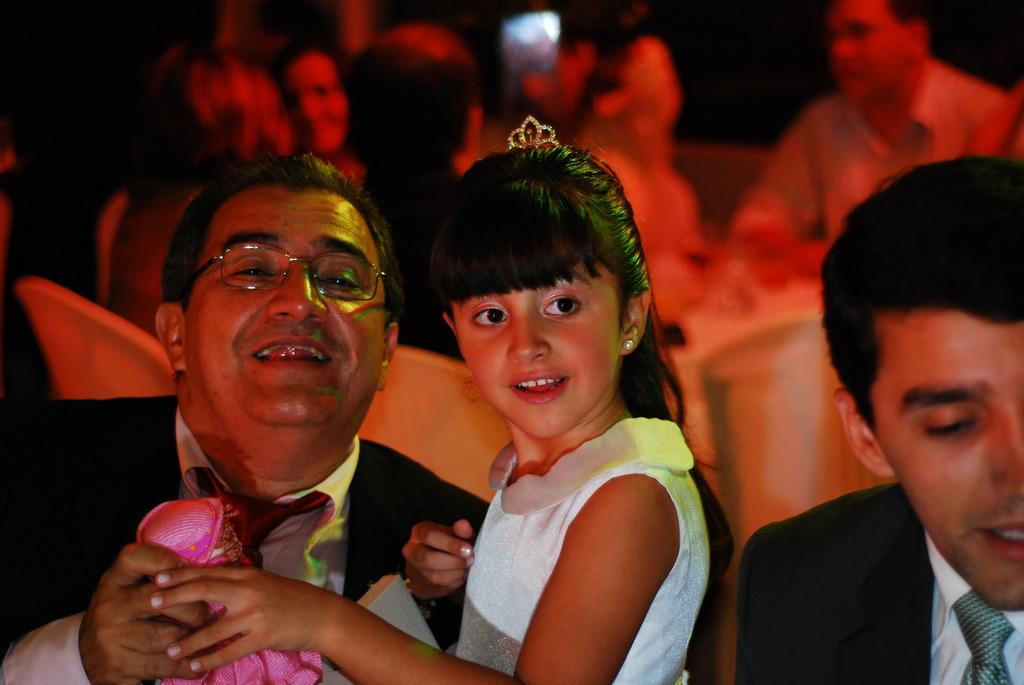What are the people in the image wearing? The people in the image are wearing clothes. Can you describe the activity of one of the people in the image? A person is holding a doll in the bottom left of the image. What can be observed about the background of the image? The background of the image is blurred. What type of sponge is being used to clean the doll in the image? There is no sponge present in the image, and the doll is not being cleaned. 